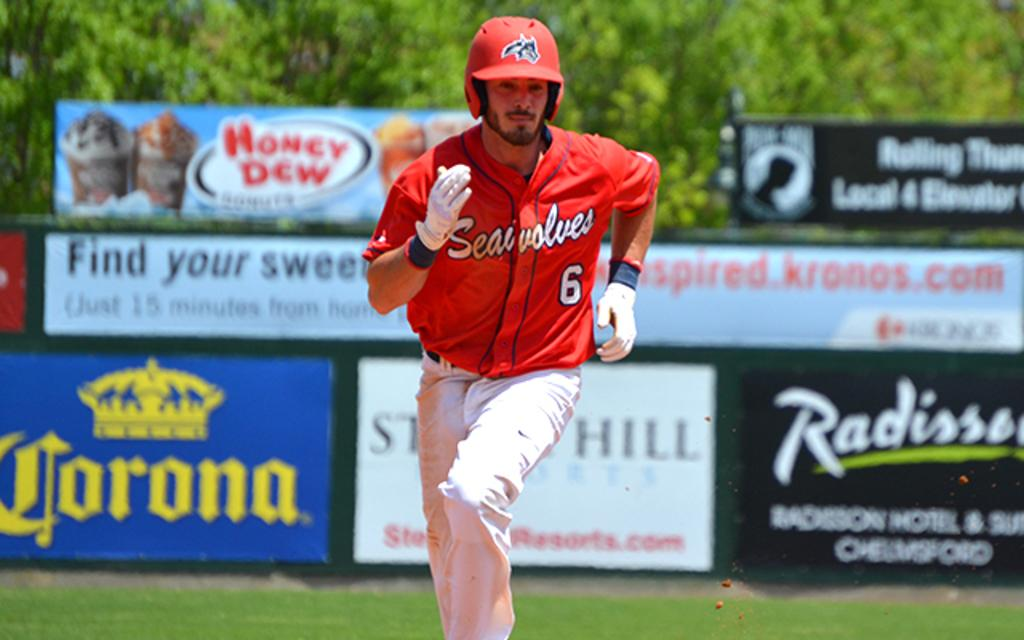<image>
Present a compact description of the photo's key features. Number 6 is shown on the jersey of the player rounding the bases. 